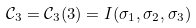Convert formula to latex. <formula><loc_0><loc_0><loc_500><loc_500>\mathcal { C } _ { 3 } = \mathcal { C } _ { 3 } ( 3 ) = I ( \sigma _ { 1 } , \sigma _ { 2 } , \sigma _ { 3 } )</formula> 